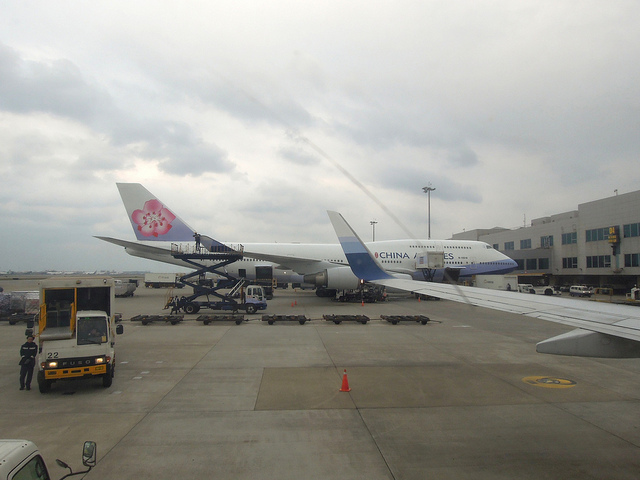Please transcribe the text in this image. CHINA 22 